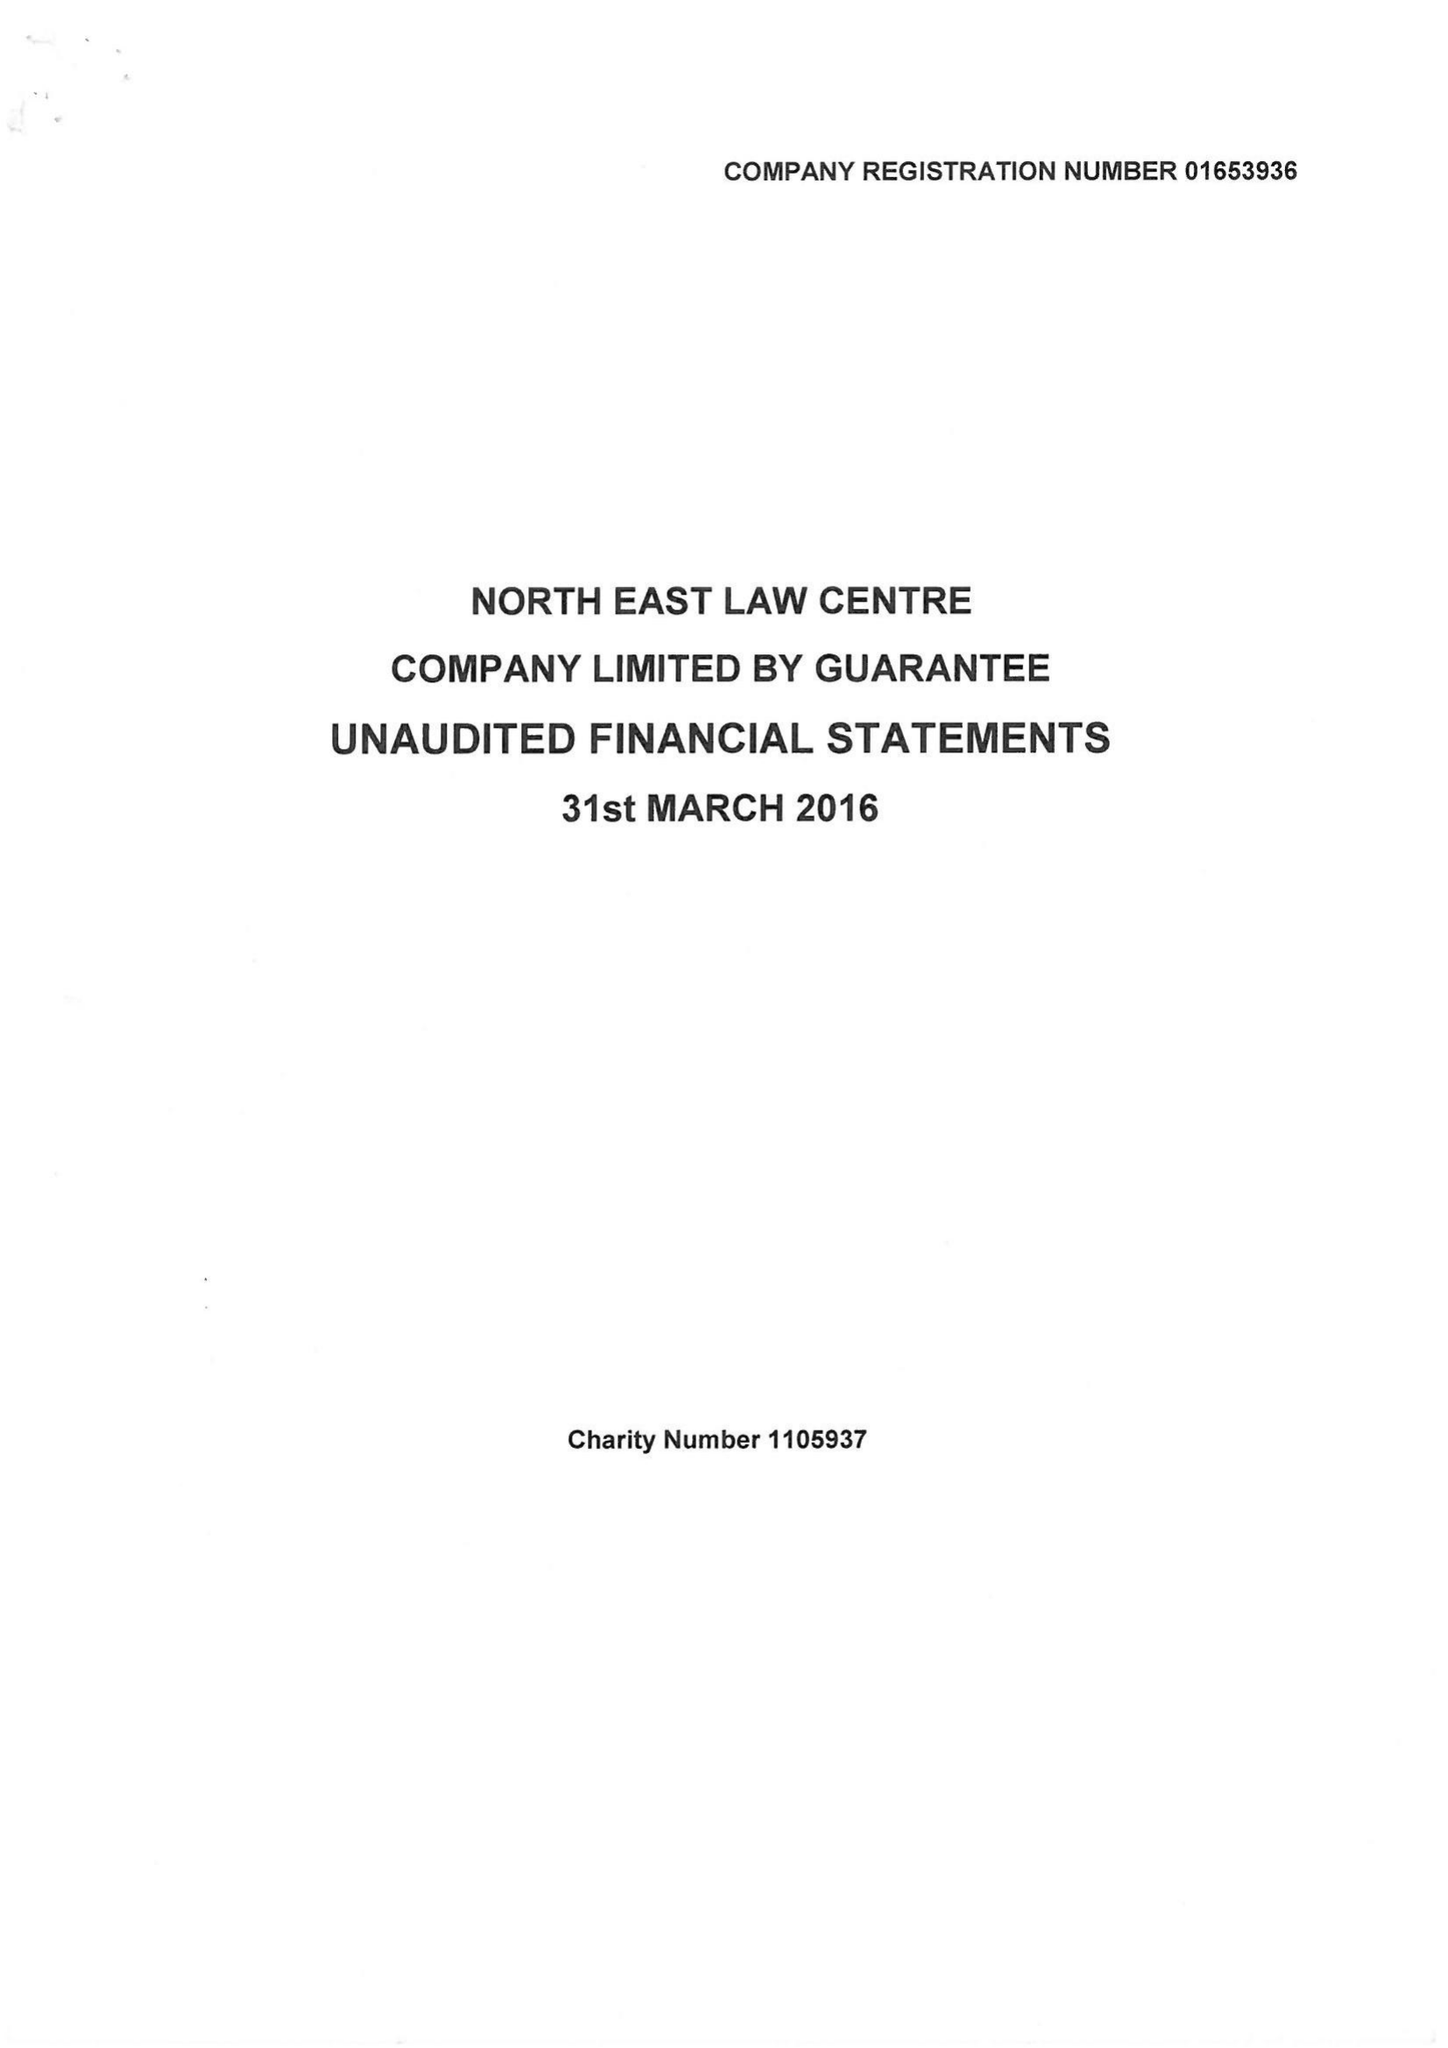What is the value for the charity_name?
Answer the question using a single word or phrase. North East Law Centre 